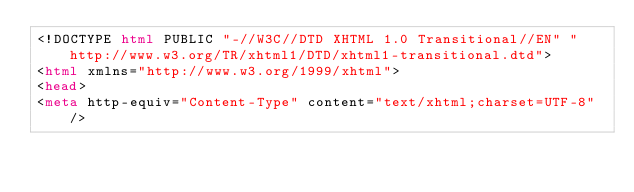Convert code to text. <code><loc_0><loc_0><loc_500><loc_500><_HTML_><!DOCTYPE html PUBLIC "-//W3C//DTD XHTML 1.0 Transitional//EN" "http://www.w3.org/TR/xhtml1/DTD/xhtml1-transitional.dtd">
<html xmlns="http://www.w3.org/1999/xhtml">
<head>
<meta http-equiv="Content-Type" content="text/xhtml;charset=UTF-8"/></code> 